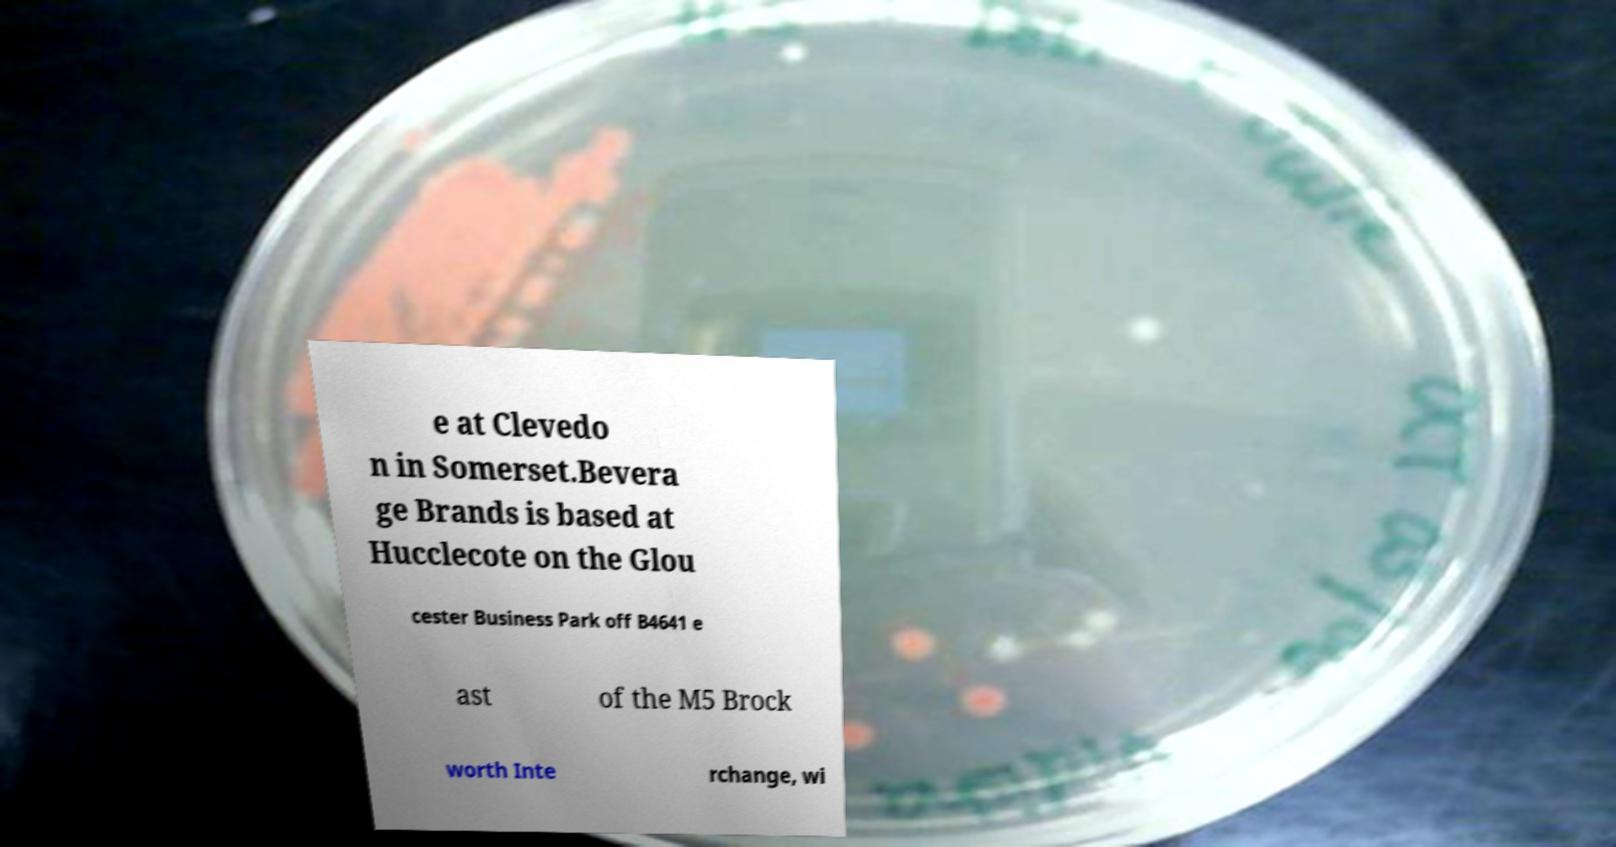Can you read and provide the text displayed in the image?This photo seems to have some interesting text. Can you extract and type it out for me? e at Clevedo n in Somerset.Bevera ge Brands is based at Hucclecote on the Glou cester Business Park off B4641 e ast of the M5 Brock worth Inte rchange, wi 